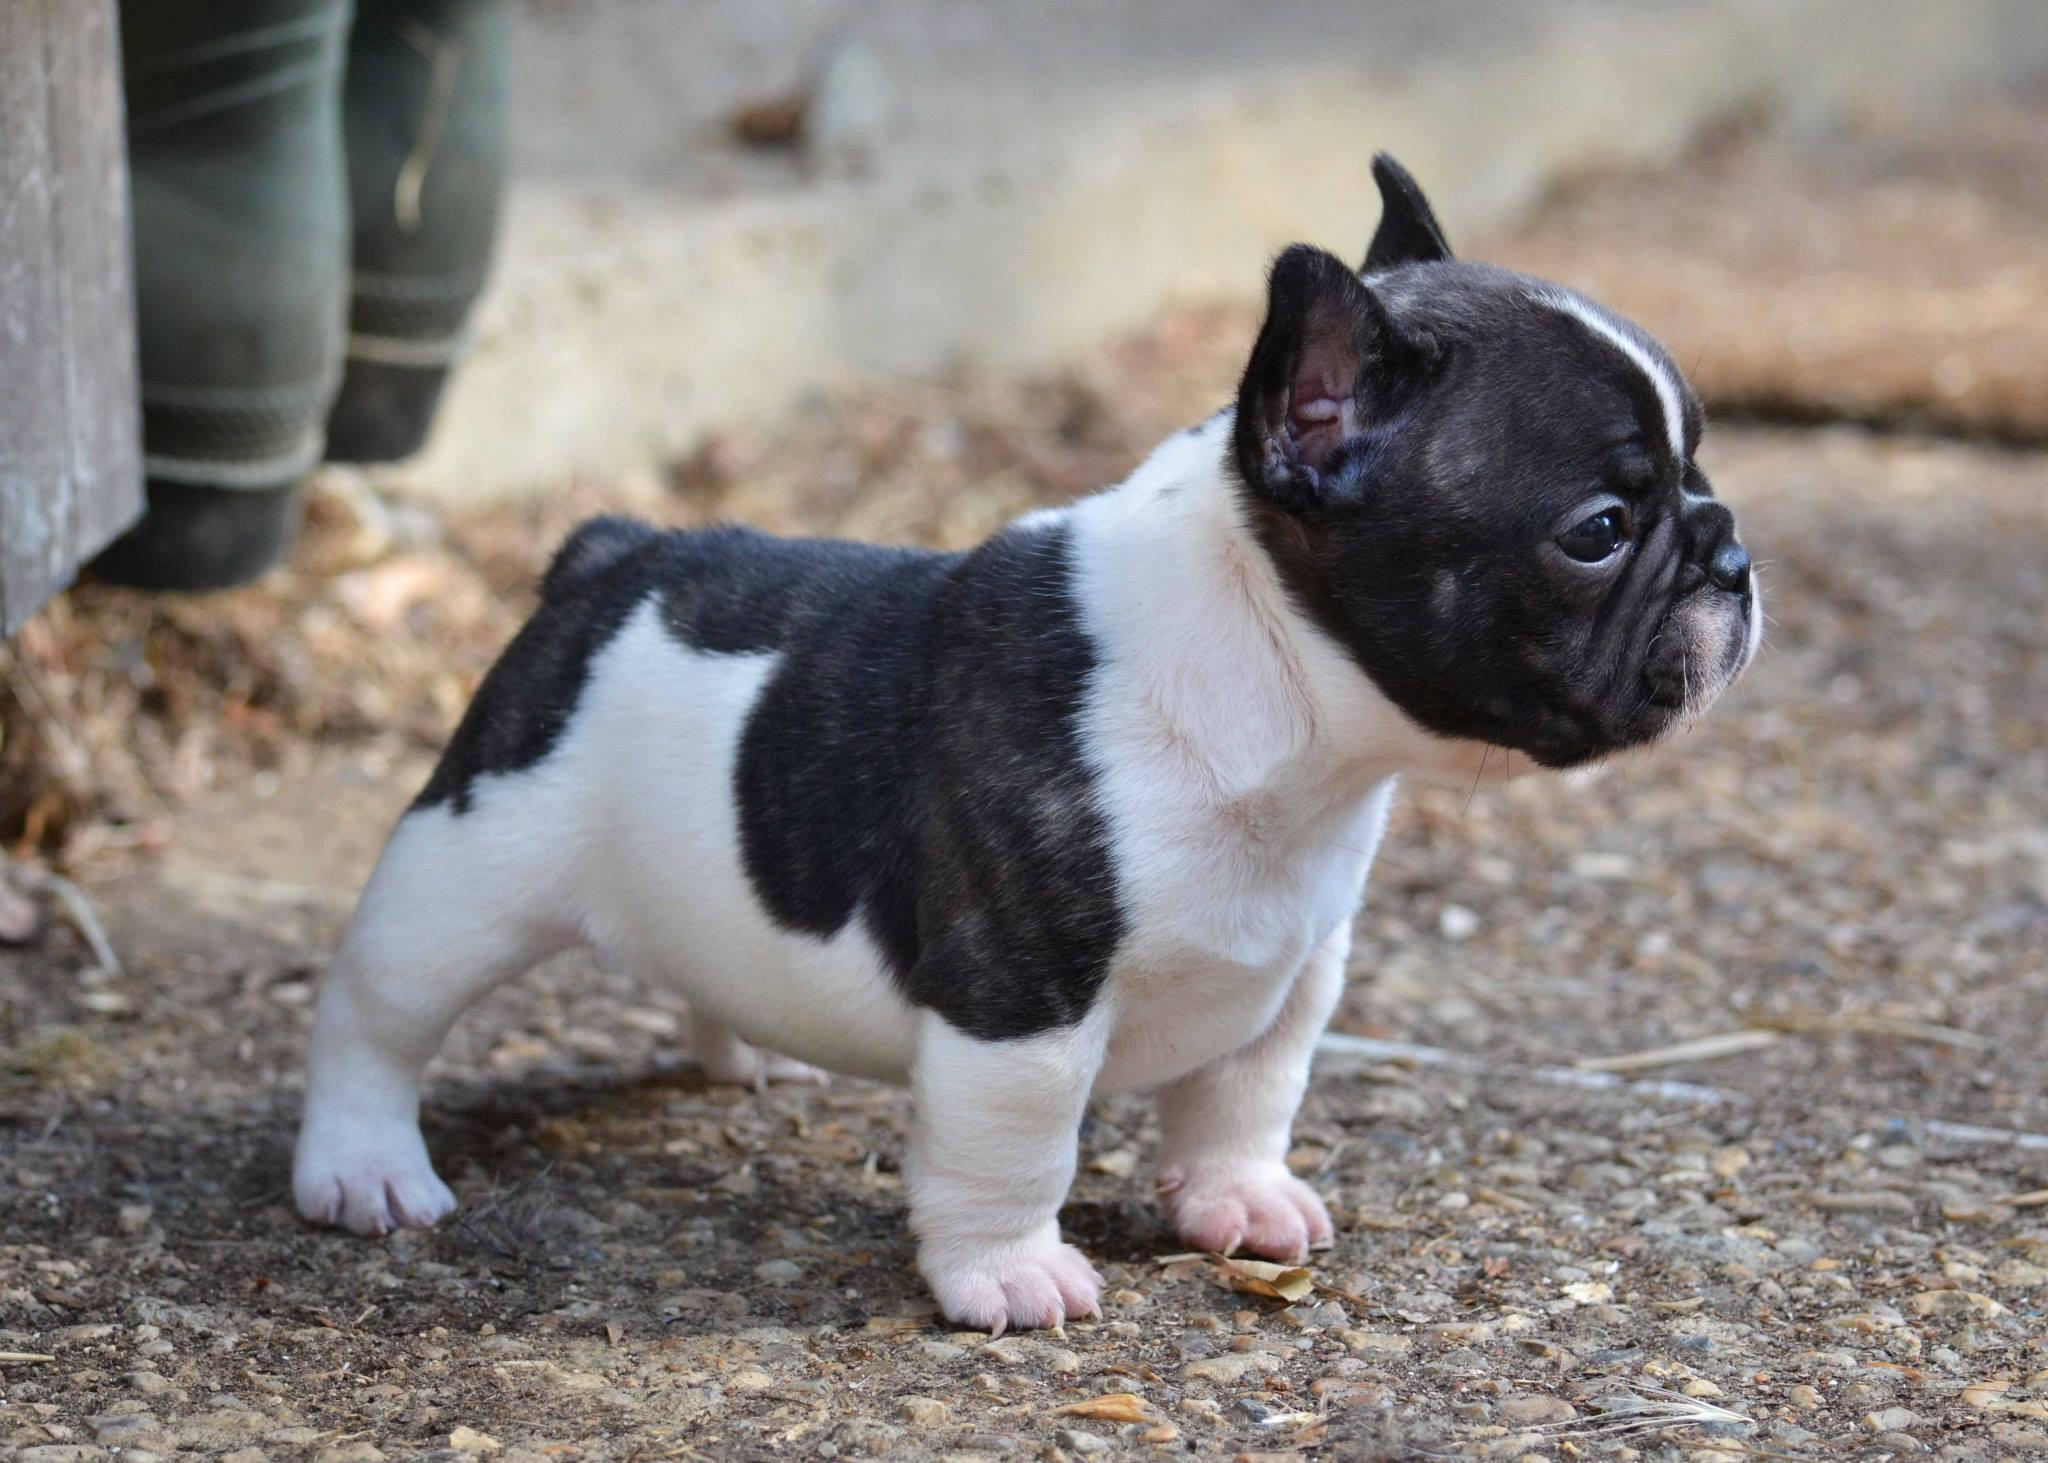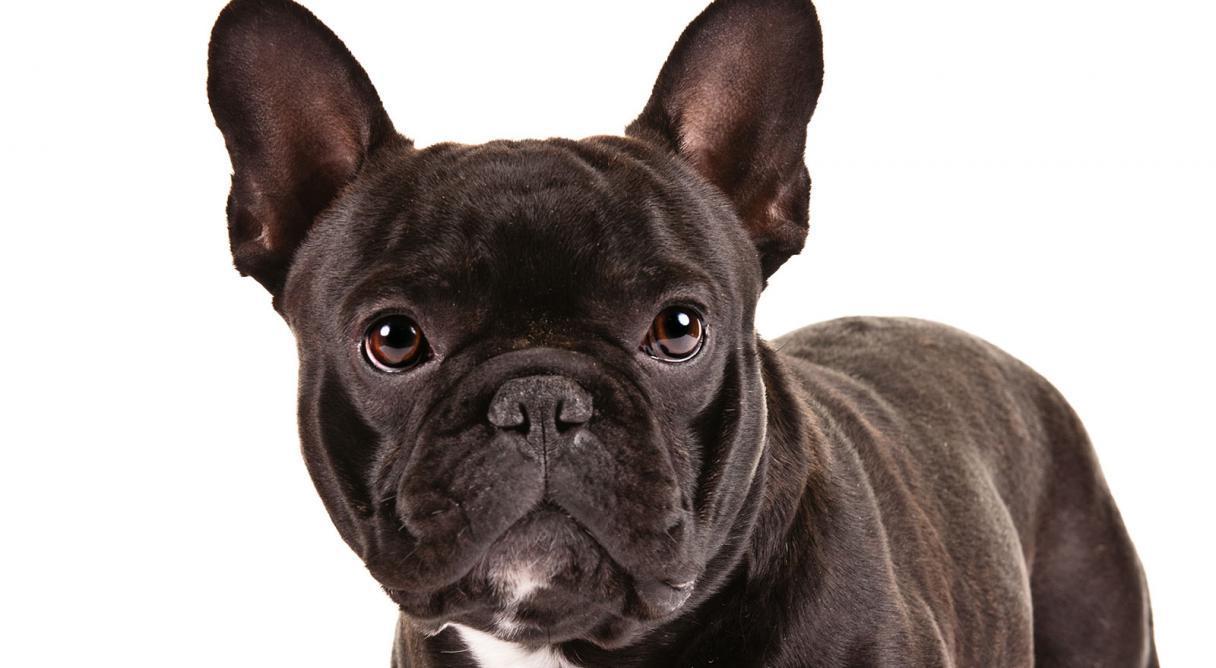The first image is the image on the left, the second image is the image on the right. Given the left and right images, does the statement "In the left image, a french bull dog puppy is standing and facing toward the right" hold true? Answer yes or no. Yes. 